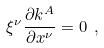<formula> <loc_0><loc_0><loc_500><loc_500>\xi ^ { \nu } \frac { \partial k ^ { A } } { \partial x ^ { \nu } } = 0 \ ,</formula> 